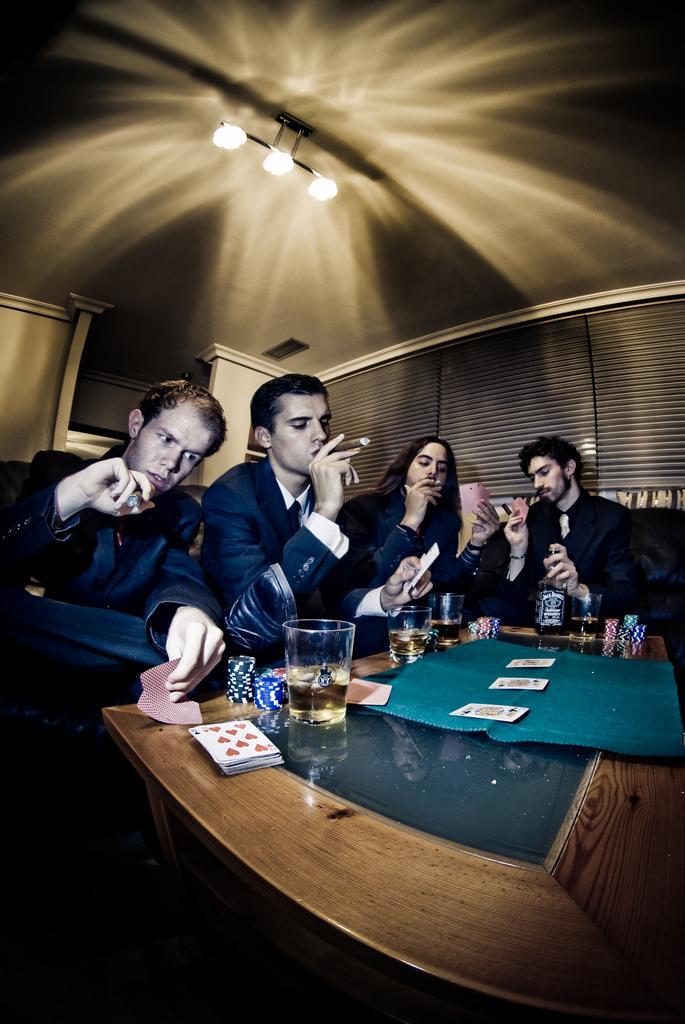How would you summarize this image in a sentence or two? In this image we can see four persons are sitting and holding cigars in their hands. There are glasses with drinks, dice, playing cards on the table. In the background we can see lights on the ceiling. 